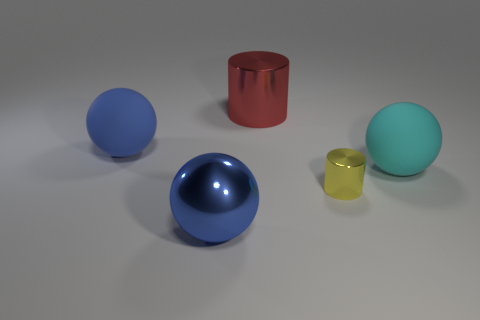There is a large metal thing in front of the blue matte ball; is it the same color as the rubber object left of the red object?
Offer a very short reply. Yes. Is there anything else that has the same size as the yellow metallic cylinder?
Keep it short and to the point. No. There is a rubber thing behind the big cyan object; does it have the same shape as the matte thing right of the red metal cylinder?
Your answer should be compact. Yes. What size is the ball that is behind the shiny sphere and in front of the blue rubber sphere?
Make the answer very short. Large. The other metallic thing that is the same shape as the small thing is what color?
Offer a very short reply. Red. What is the shape of the large object that is in front of the big blue rubber object and on the right side of the big blue metal thing?
Your answer should be very brief. Sphere. What color is the big cylinder that is made of the same material as the small thing?
Keep it short and to the point. Red. What is the shape of the large blue object that is in front of the large rubber object that is to the right of the cylinder that is behind the big cyan rubber thing?
Make the answer very short. Sphere. What size is the red thing?
Give a very brief answer. Large. What shape is the large red thing that is the same material as the tiny cylinder?
Make the answer very short. Cylinder. 